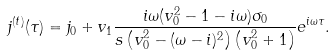Convert formula to latex. <formula><loc_0><loc_0><loc_500><loc_500>j ^ { ( t ) } ( \tau ) = j _ { 0 } + v _ { 1 } \frac { i \omega ( v _ { 0 } ^ { 2 } - 1 - i \omega ) \sigma _ { 0 } } { s \left ( v _ { 0 } ^ { 2 } - ( \omega - i ) ^ { 2 } \right ) \left ( v _ { 0 } ^ { 2 } + 1 \right ) } e ^ { i \omega \tau } .</formula> 